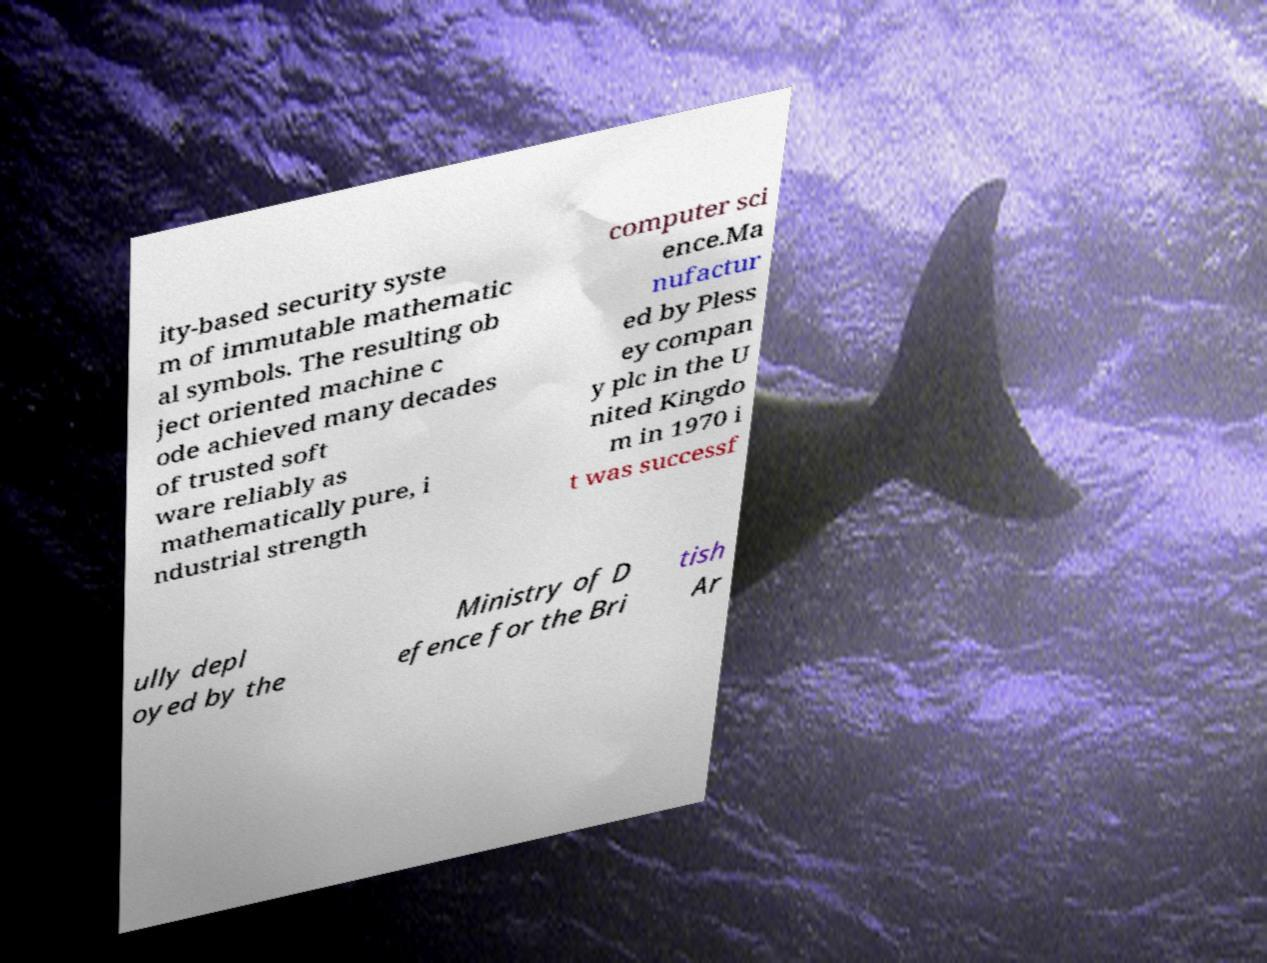What messages or text are displayed in this image? I need them in a readable, typed format. ity-based security syste m of immutable mathematic al symbols. The resulting ob ject oriented machine c ode achieved many decades of trusted soft ware reliably as mathematically pure, i ndustrial strength computer sci ence.Ma nufactur ed by Pless ey compan y plc in the U nited Kingdo m in 1970 i t was successf ully depl oyed by the Ministry of D efence for the Bri tish Ar 